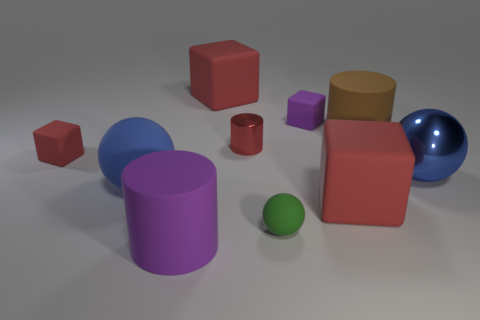What is the color of the large ball that is made of the same material as the red cylinder?
Offer a terse response. Blue. There is a purple object that is left of the purple object that is to the right of the big purple object; what is it made of?
Your response must be concise. Rubber. How many things are either red rubber cubes in front of the red metal thing or large blue objects to the left of the tiny red metallic cylinder?
Your answer should be compact. 3. What is the size of the red rubber thing that is behind the cylinder to the right of the large cube on the right side of the purple rubber cube?
Provide a short and direct response. Large. Is the number of brown things that are on the left side of the red metallic cylinder the same as the number of tiny cyan rubber objects?
Keep it short and to the point. Yes. Is there any other thing that has the same shape as the big blue rubber thing?
Keep it short and to the point. Yes. Does the red shiny thing have the same shape as the large red object that is behind the brown object?
Your answer should be very brief. No. The brown matte object that is the same shape as the small shiny thing is what size?
Your answer should be compact. Large. What number of other objects are there of the same material as the brown thing?
Offer a very short reply. 7. What is the material of the small red cylinder?
Give a very brief answer. Metal. 